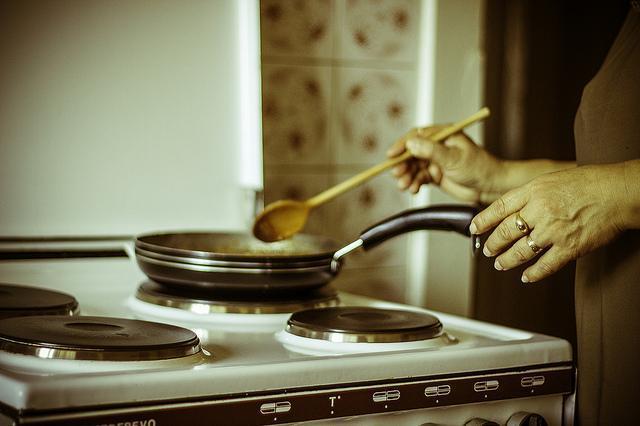How many red cars are there?
Give a very brief answer. 0. 